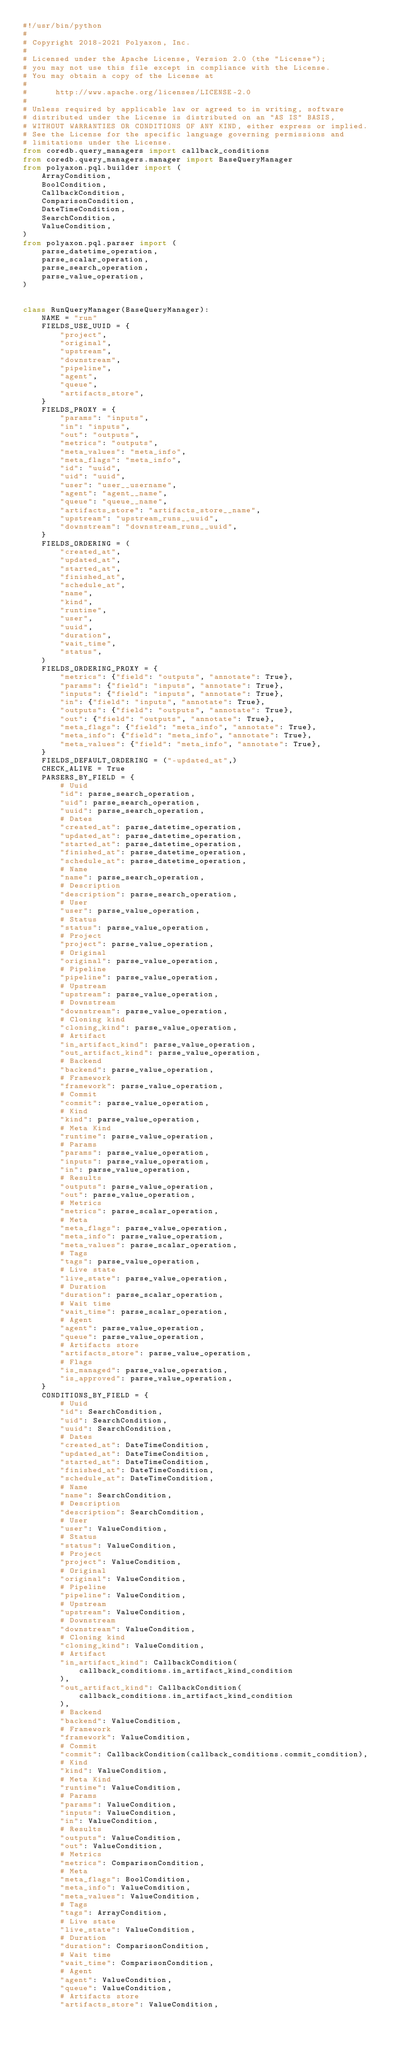Convert code to text. <code><loc_0><loc_0><loc_500><loc_500><_Python_>#!/usr/bin/python
#
# Copyright 2018-2021 Polyaxon, Inc.
#
# Licensed under the Apache License, Version 2.0 (the "License");
# you may not use this file except in compliance with the License.
# You may obtain a copy of the License at
#
#      http://www.apache.org/licenses/LICENSE-2.0
#
# Unless required by applicable law or agreed to in writing, software
# distributed under the License is distributed on an "AS IS" BASIS,
# WITHOUT WARRANTIES OR CONDITIONS OF ANY KIND, either express or implied.
# See the License for the specific language governing permissions and
# limitations under the License.
from coredb.query_managers import callback_conditions
from coredb.query_managers.manager import BaseQueryManager
from polyaxon.pql.builder import (
    ArrayCondition,
    BoolCondition,
    CallbackCondition,
    ComparisonCondition,
    DateTimeCondition,
    SearchCondition,
    ValueCondition,
)
from polyaxon.pql.parser import (
    parse_datetime_operation,
    parse_scalar_operation,
    parse_search_operation,
    parse_value_operation,
)


class RunQueryManager(BaseQueryManager):
    NAME = "run"
    FIELDS_USE_UUID = {
        "project",
        "original",
        "upstream",
        "downstream",
        "pipeline",
        "agent",
        "queue",
        "artifacts_store",
    }
    FIELDS_PROXY = {
        "params": "inputs",
        "in": "inputs",
        "out": "outputs",
        "metrics": "outputs",
        "meta_values": "meta_info",
        "meta_flags": "meta_info",
        "id": "uuid",
        "uid": "uuid",
        "user": "user__username",
        "agent": "agent__name",
        "queue": "queue__name",
        "artifacts_store": "artifacts_store__name",
        "upstream": "upstream_runs__uuid",
        "downstream": "downstream_runs__uuid",
    }
    FIELDS_ORDERING = (
        "created_at",
        "updated_at",
        "started_at",
        "finished_at",
        "schedule_at",
        "name",
        "kind",
        "runtime",
        "user",
        "uuid",
        "duration",
        "wait_time",
        "status",
    )
    FIELDS_ORDERING_PROXY = {
        "metrics": {"field": "outputs", "annotate": True},
        "params": {"field": "inputs", "annotate": True},
        "inputs": {"field": "inputs", "annotate": True},
        "in": {"field": "inputs", "annotate": True},
        "outputs": {"field": "outputs", "annotate": True},
        "out": {"field": "outputs", "annotate": True},
        "meta_flags": {"field": "meta_info", "annotate": True},
        "meta_info": {"field": "meta_info", "annotate": True},
        "meta_values": {"field": "meta_info", "annotate": True},
    }
    FIELDS_DEFAULT_ORDERING = ("-updated_at",)
    CHECK_ALIVE = True
    PARSERS_BY_FIELD = {
        # Uuid
        "id": parse_search_operation,
        "uid": parse_search_operation,
        "uuid": parse_search_operation,
        # Dates
        "created_at": parse_datetime_operation,
        "updated_at": parse_datetime_operation,
        "started_at": parse_datetime_operation,
        "finished_at": parse_datetime_operation,
        "schedule_at": parse_datetime_operation,
        # Name
        "name": parse_search_operation,
        # Description
        "description": parse_search_operation,
        # User
        "user": parse_value_operation,
        # Status
        "status": parse_value_operation,
        # Project
        "project": parse_value_operation,
        # Original
        "original": parse_value_operation,
        # Pipeline
        "pipeline": parse_value_operation,
        # Upstream
        "upstream": parse_value_operation,
        # Downstream
        "downstream": parse_value_operation,
        # Cloning kind
        "cloning_kind": parse_value_operation,
        # Artifact
        "in_artifact_kind": parse_value_operation,
        "out_artifact_kind": parse_value_operation,
        # Backend
        "backend": parse_value_operation,
        # Framework
        "framework": parse_value_operation,
        # Commit
        "commit": parse_value_operation,
        # Kind
        "kind": parse_value_operation,
        # Meta Kind
        "runtime": parse_value_operation,
        # Params
        "params": parse_value_operation,
        "inputs": parse_value_operation,
        "in": parse_value_operation,
        # Results
        "outputs": parse_value_operation,
        "out": parse_value_operation,
        # Metrics
        "metrics": parse_scalar_operation,
        # Meta
        "meta_flags": parse_value_operation,
        "meta_info": parse_value_operation,
        "meta_values": parse_scalar_operation,
        # Tags
        "tags": parse_value_operation,
        # Live state
        "live_state": parse_value_operation,
        # Duration
        "duration": parse_scalar_operation,
        # Wait time
        "wait_time": parse_scalar_operation,
        # Agent
        "agent": parse_value_operation,
        "queue": parse_value_operation,
        # Artifacts store
        "artifacts_store": parse_value_operation,
        # Flags
        "is_managed": parse_value_operation,
        "is_approved": parse_value_operation,
    }
    CONDITIONS_BY_FIELD = {
        # Uuid
        "id": SearchCondition,
        "uid": SearchCondition,
        "uuid": SearchCondition,
        # Dates
        "created_at": DateTimeCondition,
        "updated_at": DateTimeCondition,
        "started_at": DateTimeCondition,
        "finished_at": DateTimeCondition,
        "schedule_at": DateTimeCondition,
        # Name
        "name": SearchCondition,
        # Description
        "description": SearchCondition,
        # User
        "user": ValueCondition,
        # Status
        "status": ValueCondition,
        # Project
        "project": ValueCondition,
        # Original
        "original": ValueCondition,
        # Pipeline
        "pipeline": ValueCondition,
        # Upstream
        "upstream": ValueCondition,
        # Downstream
        "downstream": ValueCondition,
        # Cloning kind
        "cloning_kind": ValueCondition,
        # Artifact
        "in_artifact_kind": CallbackCondition(
            callback_conditions.in_artifact_kind_condition
        ),
        "out_artifact_kind": CallbackCondition(
            callback_conditions.in_artifact_kind_condition
        ),
        # Backend
        "backend": ValueCondition,
        # Framework
        "framework": ValueCondition,
        # Commit
        "commit": CallbackCondition(callback_conditions.commit_condition),
        # Kind
        "kind": ValueCondition,
        # Meta Kind
        "runtime": ValueCondition,
        # Params
        "params": ValueCondition,
        "inputs": ValueCondition,
        "in": ValueCondition,
        # Results
        "outputs": ValueCondition,
        "out": ValueCondition,
        # Metrics
        "metrics": ComparisonCondition,
        # Meta
        "meta_flags": BoolCondition,
        "meta_info": ValueCondition,
        "meta_values": ValueCondition,
        # Tags
        "tags": ArrayCondition,
        # Live state
        "live_state": ValueCondition,
        # Duration
        "duration": ComparisonCondition,
        # Wait time
        "wait_time": ComparisonCondition,
        # Agent
        "agent": ValueCondition,
        "queue": ValueCondition,
        # Artifacts store
        "artifacts_store": ValueCondition,</code> 